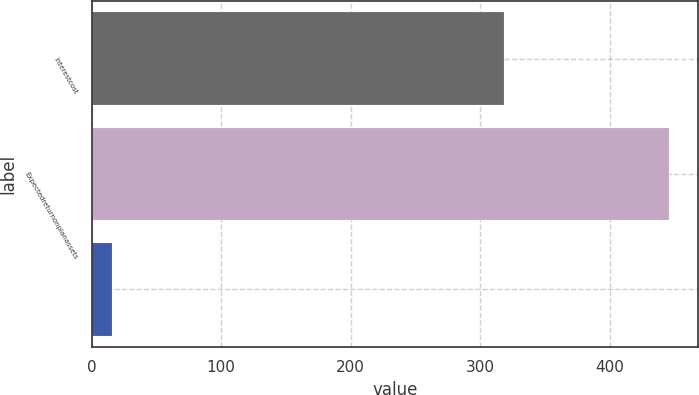Convert chart to OTSL. <chart><loc_0><loc_0><loc_500><loc_500><bar_chart><fcel>Interestcost<fcel>Expectedreturnonplanassets<fcel>Unnamed: 2<nl><fcel>318<fcel>446<fcel>16<nl></chart> 